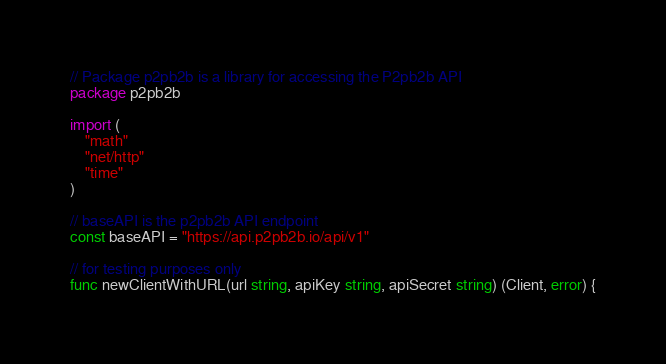Convert code to text. <code><loc_0><loc_0><loc_500><loc_500><_Go_>// Package p2pb2b is a library for accessing the P2pb2b API
package p2pb2b

import (
	"math"
	"net/http"
	"time"
)

// baseAPI is the p2pb2b API endpoint
const baseAPI = "https://api.p2pb2b.io/api/v1"

// for testing purposes only
func newClientWithURL(url string, apiKey string, apiSecret string) (Client, error) {</code> 